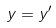Convert formula to latex. <formula><loc_0><loc_0><loc_500><loc_500>y = y ^ { \prime }</formula> 